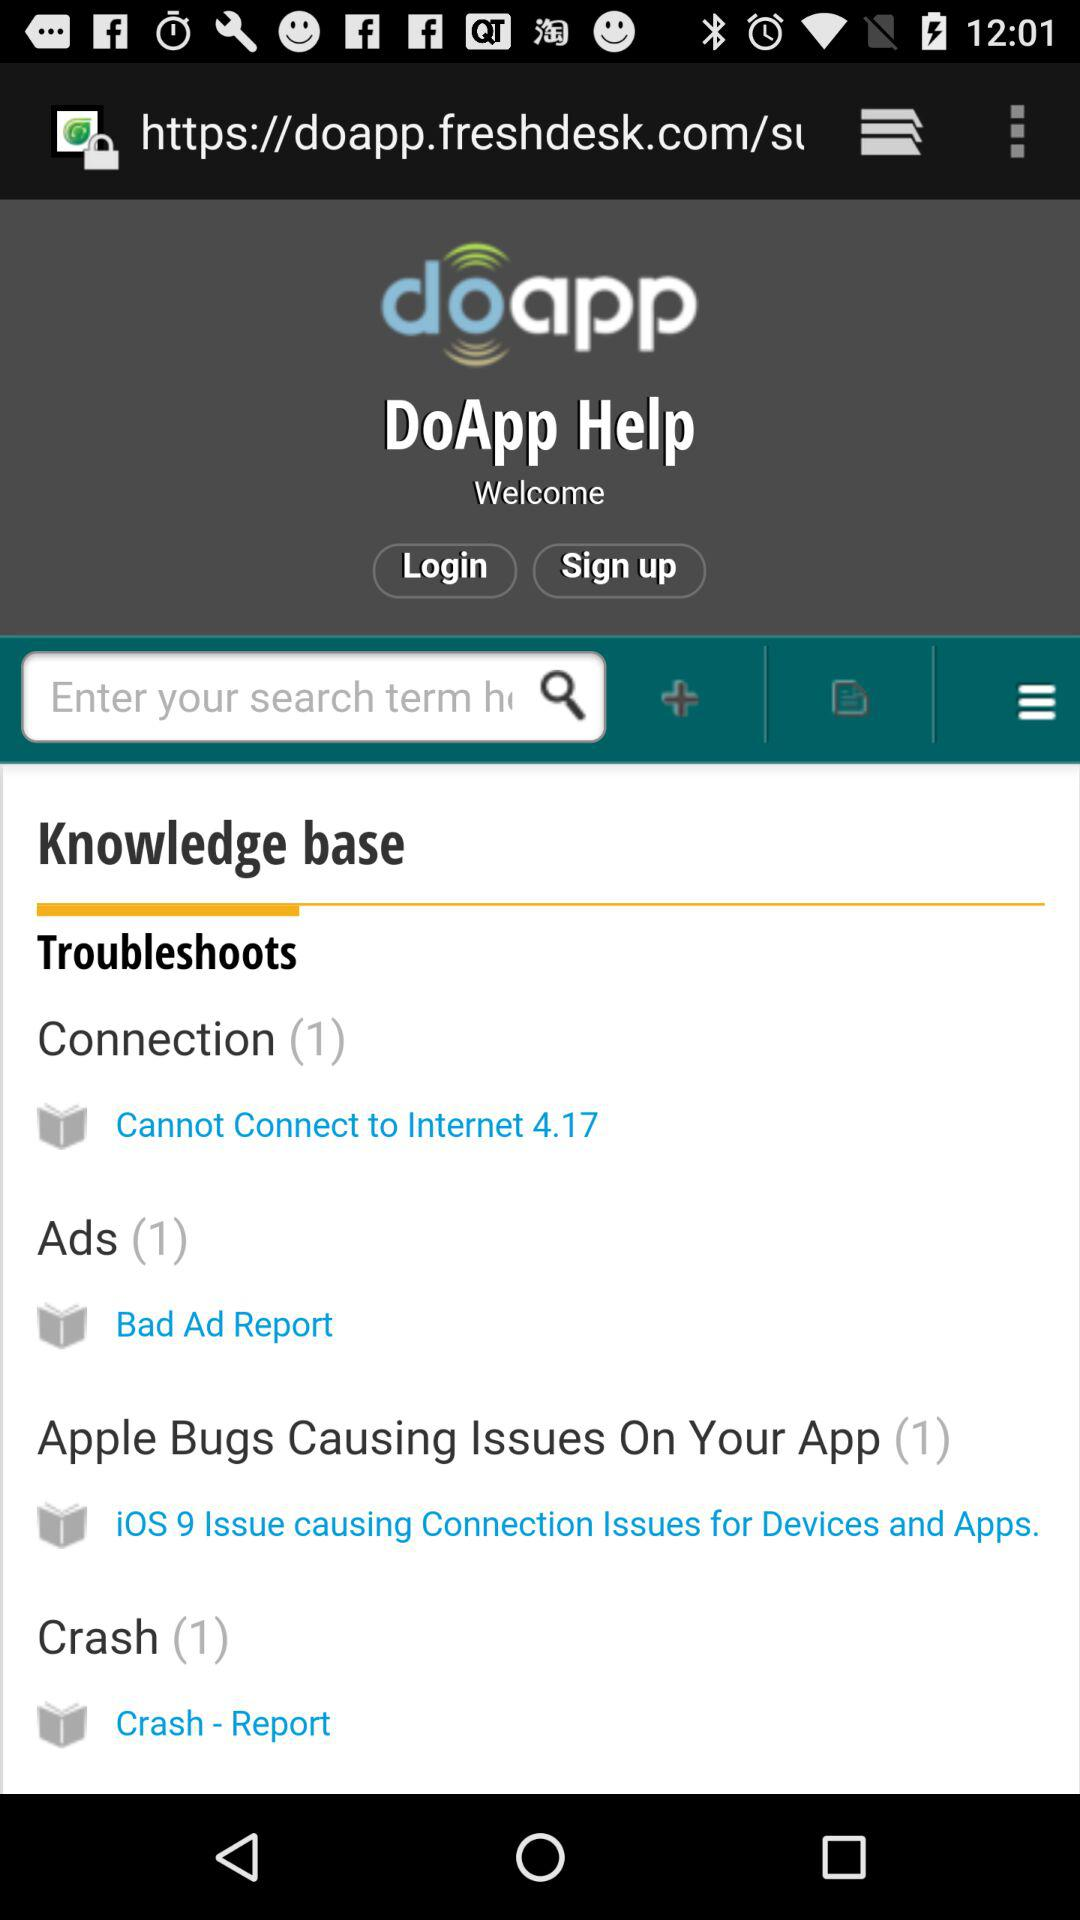What is the application name? The application name is "doapp". 